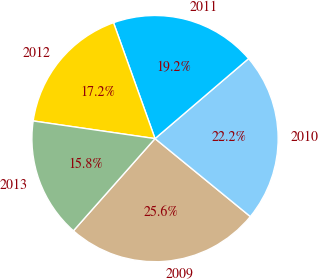Convert chart to OTSL. <chart><loc_0><loc_0><loc_500><loc_500><pie_chart><fcel>2009<fcel>2010<fcel>2011<fcel>2012<fcel>2013<nl><fcel>25.62%<fcel>22.17%<fcel>19.21%<fcel>17.24%<fcel>15.76%<nl></chart> 